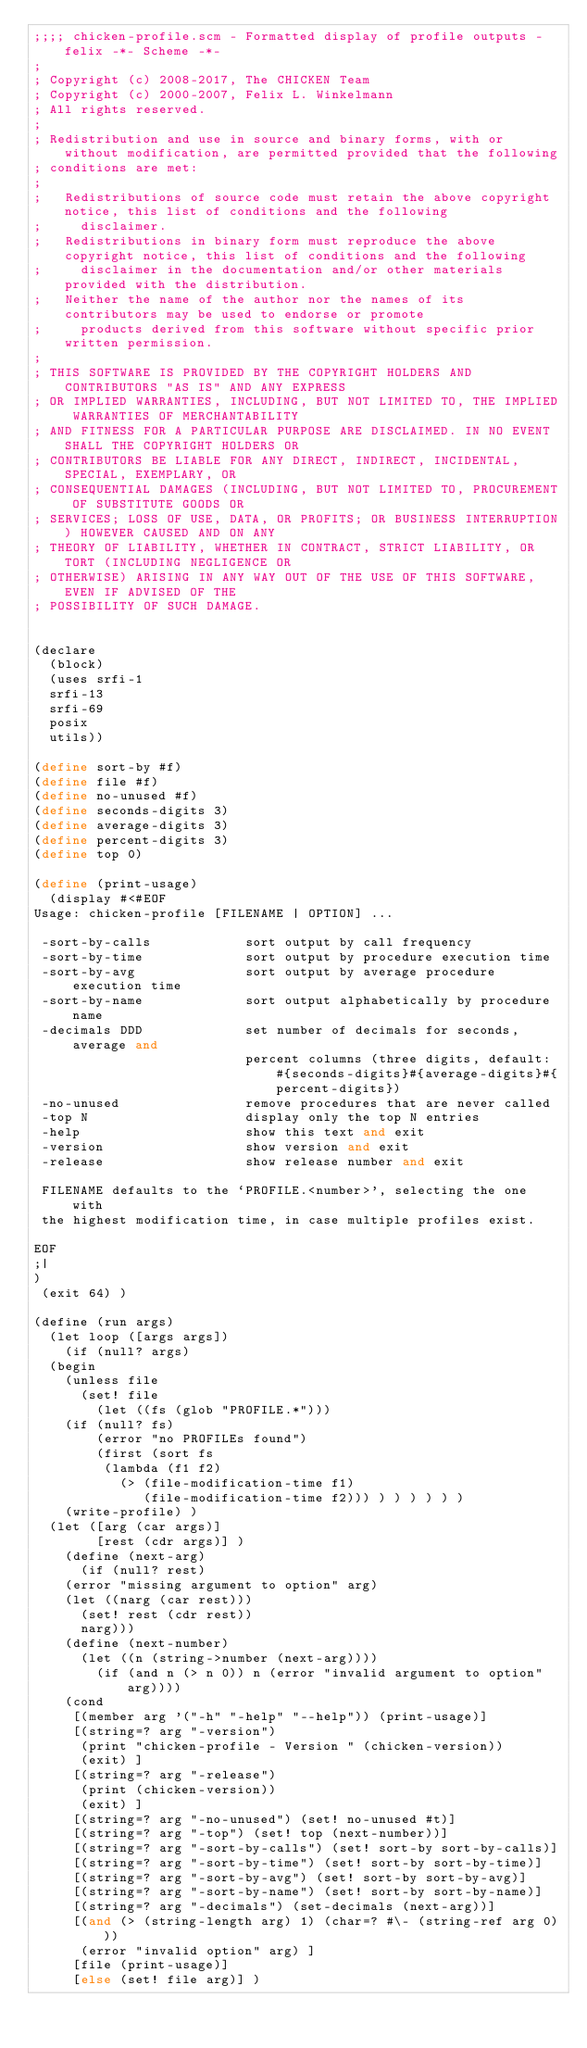<code> <loc_0><loc_0><loc_500><loc_500><_Scheme_>;;;; chicken-profile.scm - Formatted display of profile outputs - felix -*- Scheme -*-
;
; Copyright (c) 2008-2017, The CHICKEN Team
; Copyright (c) 2000-2007, Felix L. Winkelmann
; All rights reserved.
;
; Redistribution and use in source and binary forms, with or without modification, are permitted provided that the following
; conditions are met:
;
;   Redistributions of source code must retain the above copyright notice, this list of conditions and the following
;     disclaimer.
;   Redistributions in binary form must reproduce the above copyright notice, this list of conditions and the following
;     disclaimer in the documentation and/or other materials provided with the distribution.
;   Neither the name of the author nor the names of its contributors may be used to endorse or promote
;     products derived from this software without specific prior written permission.
;
; THIS SOFTWARE IS PROVIDED BY THE COPYRIGHT HOLDERS AND CONTRIBUTORS "AS IS" AND ANY EXPRESS
; OR IMPLIED WARRANTIES, INCLUDING, BUT NOT LIMITED TO, THE IMPLIED WARRANTIES OF MERCHANTABILITY
; AND FITNESS FOR A PARTICULAR PURPOSE ARE DISCLAIMED. IN NO EVENT SHALL THE COPYRIGHT HOLDERS OR
; CONTRIBUTORS BE LIABLE FOR ANY DIRECT, INDIRECT, INCIDENTAL, SPECIAL, EXEMPLARY, OR
; CONSEQUENTIAL DAMAGES (INCLUDING, BUT NOT LIMITED TO, PROCUREMENT OF SUBSTITUTE GOODS OR
; SERVICES; LOSS OF USE, DATA, OR PROFITS; OR BUSINESS INTERRUPTION) HOWEVER CAUSED AND ON ANY
; THEORY OF LIABILITY, WHETHER IN CONTRACT, STRICT LIABILITY, OR TORT (INCLUDING NEGLIGENCE OR
; OTHERWISE) ARISING IN ANY WAY OUT OF THE USE OF THIS SOFTWARE, EVEN IF ADVISED OF THE
; POSSIBILITY OF SUCH DAMAGE.


(declare
  (block)
  (uses srfi-1
	srfi-13
	srfi-69
	posix
	utils))

(define sort-by #f)
(define file #f)
(define no-unused #f)
(define seconds-digits 3)
(define average-digits 3)
(define percent-digits 3)
(define top 0)

(define (print-usage)
  (display #<#EOF
Usage: chicken-profile [FILENAME | OPTION] ...

 -sort-by-calls            sort output by call frequency
 -sort-by-time             sort output by procedure execution time
 -sort-by-avg              sort output by average procedure execution time
 -sort-by-name             sort output alphabetically by procedure name
 -decimals DDD             set number of decimals for seconds, average and
                           percent columns (three digits, default: #{seconds-digits}#{average-digits}#{percent-digits})
 -no-unused                remove procedures that are never called
 -top N                    display only the top N entries
 -help                     show this text and exit
 -version                  show version and exit
 -release                  show release number and exit

 FILENAME defaults to the `PROFILE.<number>', selecting the one with
 the highest modification time, in case multiple profiles exist.

EOF
;|
)
 (exit 64) )

(define (run args)
  (let loop ([args args])
    (if (null? args)
	(begin
	  (unless file 
	    (set! file
	      (let ((fs (glob "PROFILE.*")))
		(if (null? fs)
		    (error "no PROFILEs found")
		    (first (sort fs 
				 (lambda (f1 f2)
				   (> (file-modification-time f1)
				      (file-modification-time f2))) ) ) ) ) ) )
	  (write-profile) )
	(let ([arg (car args)]
	      [rest (cdr args)] )
	  (define (next-arg)
	    (if (null? rest)
		(error "missing argument to option" arg)
		(let ((narg (car rest)))
		  (set! rest (cdr rest))
		  narg)))
	  (define (next-number)
	    (let ((n (string->number (next-arg))))
	      (if (and n (> n 0)) n (error "invalid argument to option" arg))))
	  (cond 
	   [(member arg '("-h" "-help" "--help")) (print-usage)]
	   [(string=? arg "-version")
	    (print "chicken-profile - Version " (chicken-version))
	    (exit) ]
	   [(string=? arg "-release")
	    (print (chicken-version))
	    (exit) ]
	   [(string=? arg "-no-unused") (set! no-unused #t)]
	   [(string=? arg "-top") (set! top (next-number))]
	   [(string=? arg "-sort-by-calls") (set! sort-by sort-by-calls)]
	   [(string=? arg "-sort-by-time") (set! sort-by sort-by-time)]
	   [(string=? arg "-sort-by-avg") (set! sort-by sort-by-avg)]
	   [(string=? arg "-sort-by-name") (set! sort-by sort-by-name)]
	   [(string=? arg "-decimals") (set-decimals (next-arg))]
	   [(and (> (string-length arg) 1) (char=? #\- (string-ref arg 0)))
	    (error "invalid option" arg) ]
	   [file (print-usage)]
	   [else (set! file arg)] )</code> 